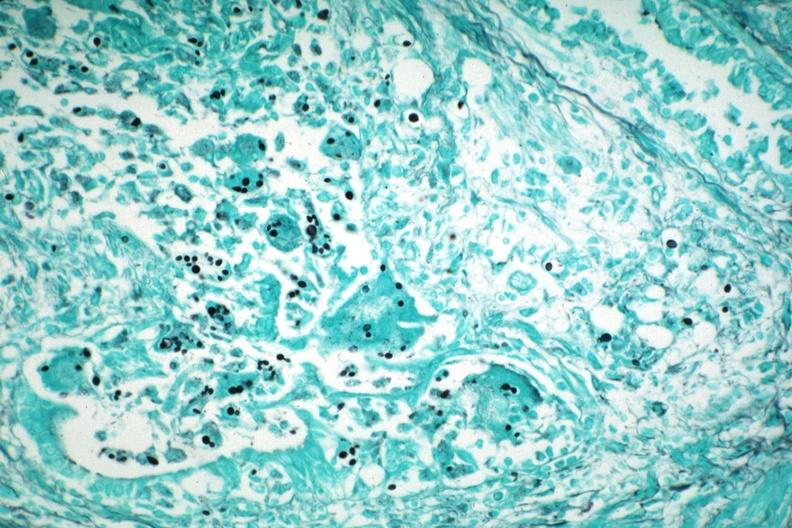does gms illustrate organisms granulomatous prostatitis aids case?
Answer the question using a single word or phrase. Yes 